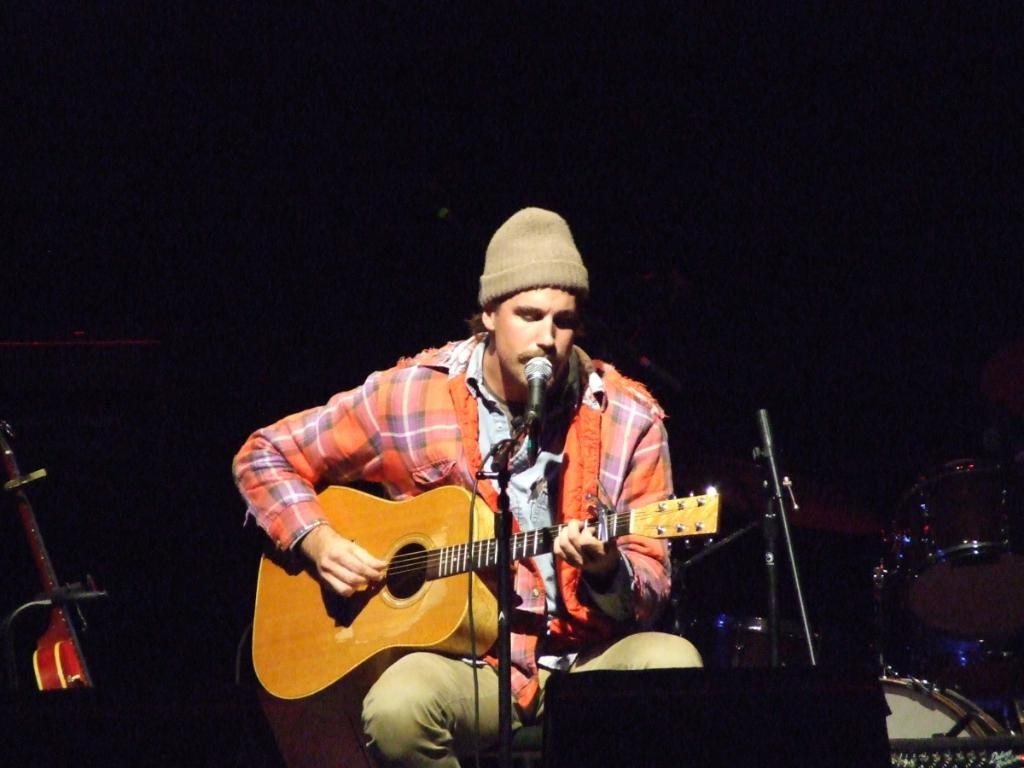What is the guy in the image doing? The guy is sitting on a chair and playing a guitar. What object is in front of the guy? There is a microphone in front of the guy. Are there any other musical instruments visible in the image? Yes, there are other musical instruments beside the guy. What type of advertisement can be seen in the garden in the image? There is no advertisement or garden present in the image; it features a guy playing a guitar with a microphone and other musical instruments nearby. 